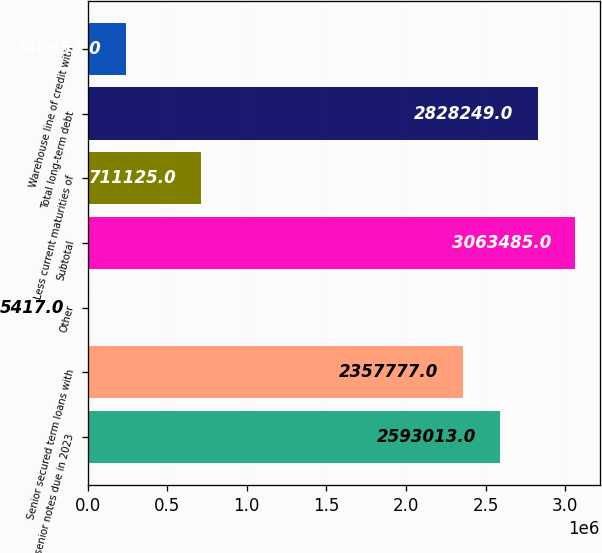Convert chart to OTSL. <chart><loc_0><loc_0><loc_500><loc_500><bar_chart><fcel>500 senior notes due in 2023<fcel>Senior secured term loans with<fcel>Other<fcel>Subtotal<fcel>Less current maturities of<fcel>Total long-term debt<fcel>Warehouse line of credit with<nl><fcel>2.59301e+06<fcel>2.35778e+06<fcel>5417<fcel>3.06348e+06<fcel>711125<fcel>2.82825e+06<fcel>240653<nl></chart> 